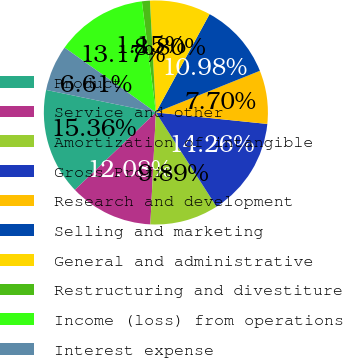Convert chart to OTSL. <chart><loc_0><loc_0><loc_500><loc_500><pie_chart><fcel>Product<fcel>Service and other<fcel>Amortization of intangible<fcel>Gross Profit<fcel>Research and development<fcel>Selling and marketing<fcel>General and administrative<fcel>Restructuring and divestiture<fcel>Income (loss) from operations<fcel>Interest expense<nl><fcel>15.36%<fcel>12.08%<fcel>9.89%<fcel>14.26%<fcel>7.7%<fcel>10.98%<fcel>8.8%<fcel>1.15%<fcel>13.17%<fcel>6.61%<nl></chart> 